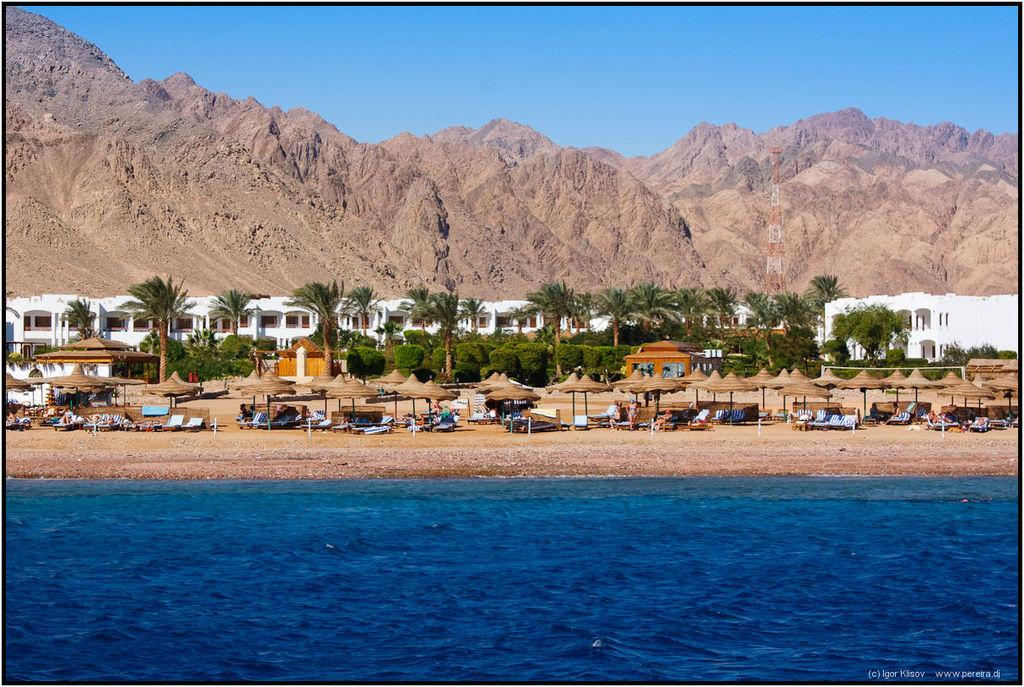What objects are arranged in a group in the image? There is a group of chairs and a group of umbrellas in the image. Where are the chairs and umbrellas located? The chairs and umbrellas are placed on the ground. What can be seen in the background of the image? There are trees, buildings, mountains, a tower, and the sky visible in the background of the image. What type of cemetery can be seen in the image? There is no cemetery present in the image; it features a group of chairs and umbrellas on the ground with various elements in the background. 